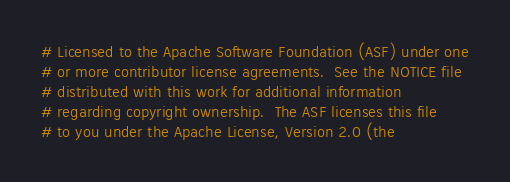Convert code to text. <code><loc_0><loc_0><loc_500><loc_500><_Python_># Licensed to the Apache Software Foundation (ASF) under one
# or more contributor license agreements.  See the NOTICE file
# distributed with this work for additional information
# regarding copyright ownership.  The ASF licenses this file
# to you under the Apache License, Version 2.0 (the</code> 